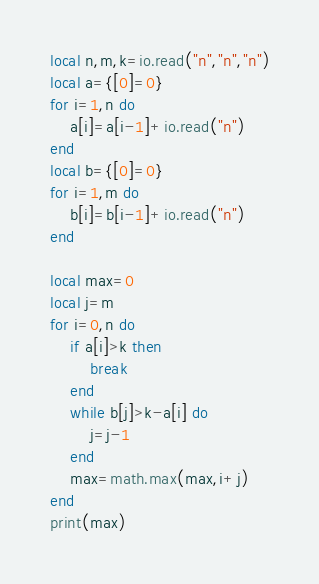Convert code to text. <code><loc_0><loc_0><loc_500><loc_500><_Lua_>local n,m,k=io.read("n","n","n")
local a={[0]=0}
for i=1,n do
    a[i]=a[i-1]+io.read("n")
end
local b={[0]=0}
for i=1,m do
    b[i]=b[i-1]+io.read("n")
end

local max=0
local j=m
for i=0,n do
    if a[i]>k then
        break
    end
    while b[j]>k-a[i] do
        j=j-1
    end
    max=math.max(max,i+j)
end
print(max)</code> 